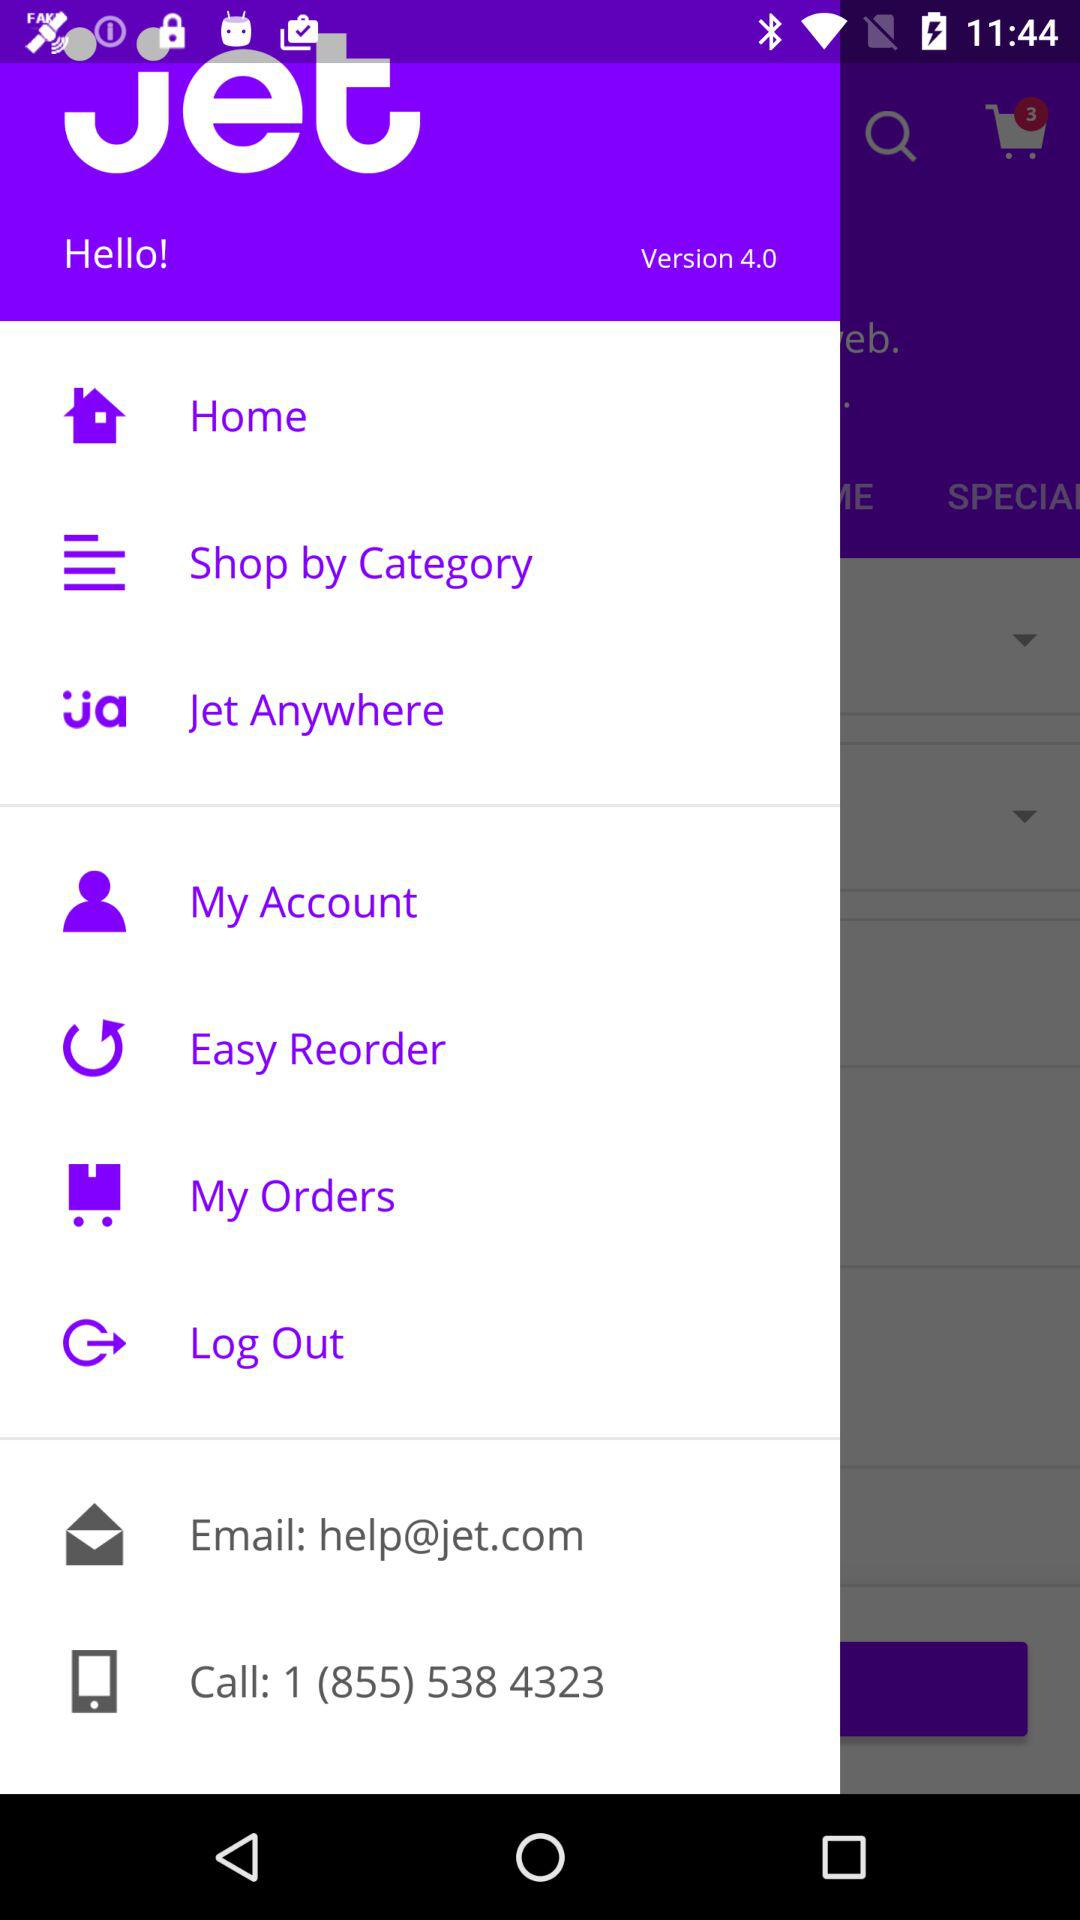What is the number to call? The number is 1 (855) 538 4323. 